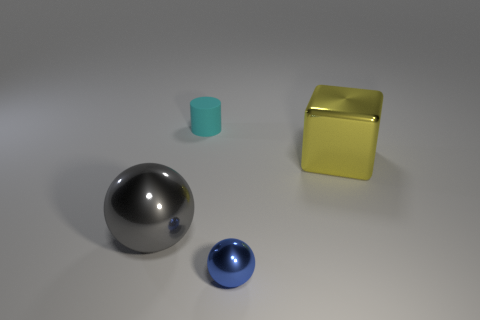Add 2 small cyan cylinders. How many objects exist? 6 Subtract all purple metallic things. Subtract all blue shiny balls. How many objects are left? 3 Add 1 big gray objects. How many big gray objects are left? 2 Add 4 tiny rubber blocks. How many tiny rubber blocks exist? 4 Subtract 1 blue spheres. How many objects are left? 3 